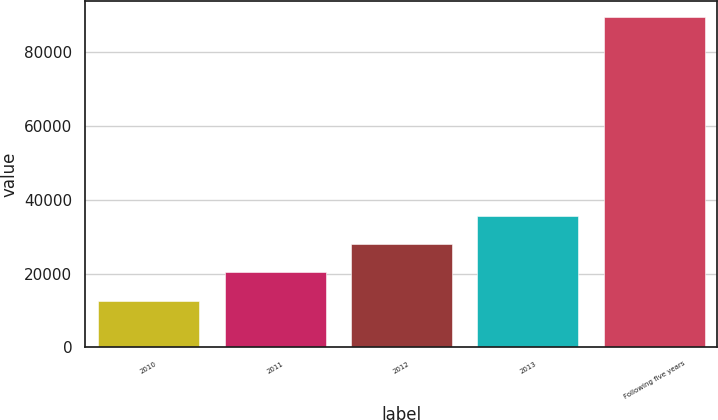Convert chart. <chart><loc_0><loc_0><loc_500><loc_500><bar_chart><fcel>2010<fcel>2011<fcel>2012<fcel>2013<fcel>Following five years<nl><fcel>12634<fcel>20324.4<fcel>28014.8<fcel>35705.2<fcel>89538<nl></chart> 